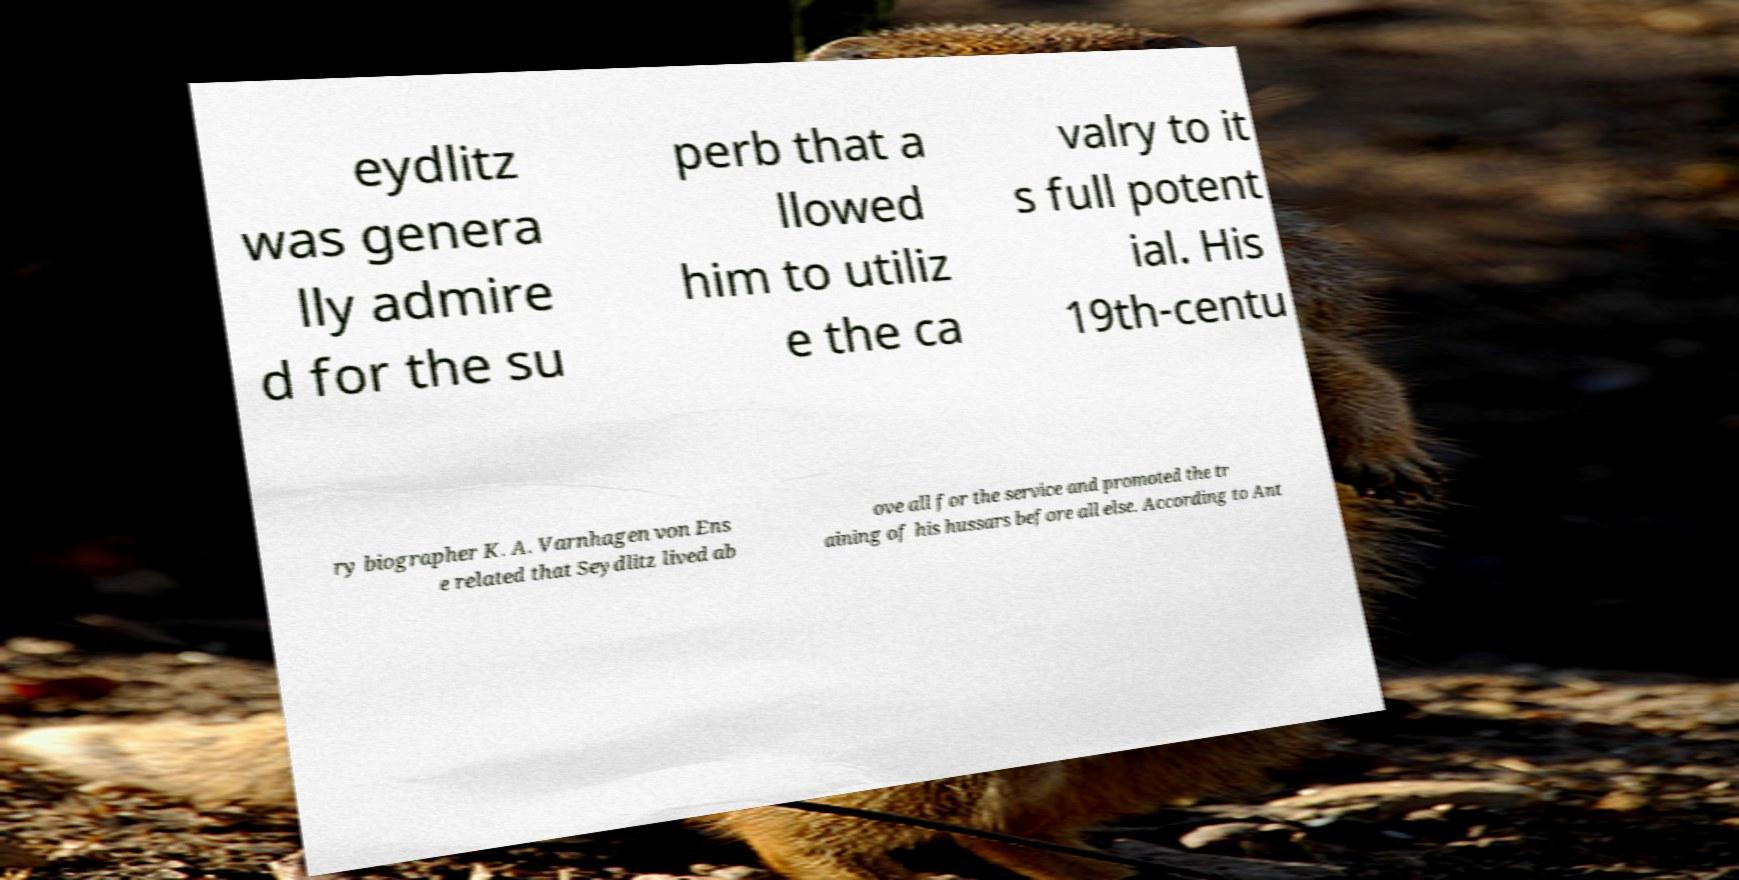What messages or text are displayed in this image? I need them in a readable, typed format. eydlitz was genera lly admire d for the su perb that a llowed him to utiliz e the ca valry to it s full potent ial. His 19th-centu ry biographer K. A. Varnhagen von Ens e related that Seydlitz lived ab ove all for the service and promoted the tr aining of his hussars before all else. According to Ant 